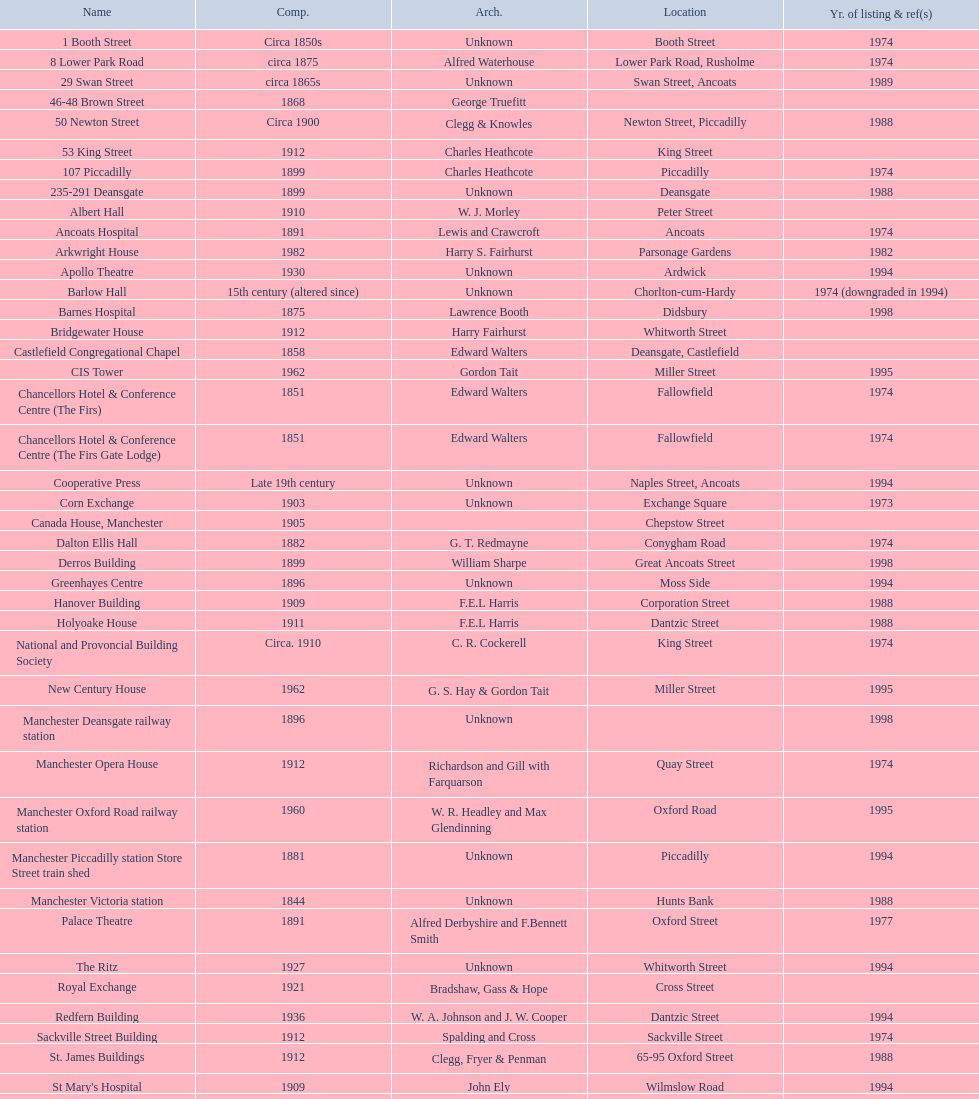Which two buildings were listed before 1974? The Old Wellington Inn, Smithfield Market Hall. Write the full table. {'header': ['Name', 'Comp.', 'Arch.', 'Location', 'Yr. of listing & ref(s)'], 'rows': [['1 Booth Street', 'Circa 1850s', 'Unknown', 'Booth Street', '1974'], ['8 Lower Park Road', 'circa 1875', 'Alfred Waterhouse', 'Lower Park Road, Rusholme', '1974'], ['29 Swan Street', 'circa 1865s', 'Unknown', 'Swan Street, Ancoats', '1989'], ['46-48 Brown Street', '1868', 'George Truefitt', '', ''], ['50 Newton Street', 'Circa 1900', 'Clegg & Knowles', 'Newton Street, Piccadilly', '1988'], ['53 King Street', '1912', 'Charles Heathcote', 'King Street', ''], ['107 Piccadilly', '1899', 'Charles Heathcote', 'Piccadilly', '1974'], ['235-291 Deansgate', '1899', 'Unknown', 'Deansgate', '1988'], ['Albert Hall', '1910', 'W. J. Morley', 'Peter Street', ''], ['Ancoats Hospital', '1891', 'Lewis and Crawcroft', 'Ancoats', '1974'], ['Arkwright House', '1982', 'Harry S. Fairhurst', 'Parsonage Gardens', '1982'], ['Apollo Theatre', '1930', 'Unknown', 'Ardwick', '1994'], ['Barlow Hall', '15th century (altered since)', 'Unknown', 'Chorlton-cum-Hardy', '1974 (downgraded in 1994)'], ['Barnes Hospital', '1875', 'Lawrence Booth', 'Didsbury', '1998'], ['Bridgewater House', '1912', 'Harry Fairhurst', 'Whitworth Street', ''], ['Castlefield Congregational Chapel', '1858', 'Edward Walters', 'Deansgate, Castlefield', ''], ['CIS Tower', '1962', 'Gordon Tait', 'Miller Street', '1995'], ['Chancellors Hotel & Conference Centre (The Firs)', '1851', 'Edward Walters', 'Fallowfield', '1974'], ['Chancellors Hotel & Conference Centre (The Firs Gate Lodge)', '1851', 'Edward Walters', 'Fallowfield', '1974'], ['Cooperative Press', 'Late 19th century', 'Unknown', 'Naples Street, Ancoats', '1994'], ['Corn Exchange', '1903', 'Unknown', 'Exchange Square', '1973'], ['Canada House, Manchester', '1905', '', 'Chepstow Street', ''], ['Dalton Ellis Hall', '1882', 'G. T. Redmayne', 'Conygham Road', '1974'], ['Derros Building', '1899', 'William Sharpe', 'Great Ancoats Street', '1998'], ['Greenhayes Centre', '1896', 'Unknown', 'Moss Side', '1994'], ['Hanover Building', '1909', 'F.E.L Harris', 'Corporation Street', '1988'], ['Holyoake House', '1911', 'F.E.L Harris', 'Dantzic Street', '1988'], ['National and Provoncial Building Society', 'Circa. 1910', 'C. R. Cockerell', 'King Street', '1974'], ['New Century House', '1962', 'G. S. Hay & Gordon Tait', 'Miller Street', '1995'], ['Manchester Deansgate railway station', '1896', 'Unknown', '', '1998'], ['Manchester Opera House', '1912', 'Richardson and Gill with Farquarson', 'Quay Street', '1974'], ['Manchester Oxford Road railway station', '1960', 'W. R. Headley and Max Glendinning', 'Oxford Road', '1995'], ['Manchester Piccadilly station Store Street train shed', '1881', 'Unknown', 'Piccadilly', '1994'], ['Manchester Victoria station', '1844', 'Unknown', 'Hunts Bank', '1988'], ['Palace Theatre', '1891', 'Alfred Derbyshire and F.Bennett Smith', 'Oxford Street', '1977'], ['The Ritz', '1927', 'Unknown', 'Whitworth Street', '1994'], ['Royal Exchange', '1921', 'Bradshaw, Gass & Hope', 'Cross Street', ''], ['Redfern Building', '1936', 'W. A. Johnson and J. W. Cooper', 'Dantzic Street', '1994'], ['Sackville Street Building', '1912', 'Spalding and Cross', 'Sackville Street', '1974'], ['St. James Buildings', '1912', 'Clegg, Fryer & Penman', '65-95 Oxford Street', '1988'], ["St Mary's Hospital", '1909', 'John Ely', 'Wilmslow Road', '1994'], ['Samuel Alexander Building', '1919', 'Percy Scott Worthington', 'Oxford Road', '2010'], ['Ship Canal House', '1927', 'Harry S. Fairhurst', 'King Street', '1982'], ['Smithfield Market Hall', '1857', 'Unknown', 'Swan Street, Ancoats', '1973'], ['Strangeways Gaol Gatehouse', '1868', 'Alfred Waterhouse', 'Sherborne Street', '1974'], ['Strangeways Prison ventilation and watch tower', '1868', 'Alfred Waterhouse', 'Sherborne Street', '1974'], ['Theatre Royal', '1845', 'Irwin and Chester', 'Peter Street', '1974'], ['Toast Rack', '1960', 'L. C. Howitt', 'Fallowfield', '1999'], ['The Old Wellington Inn', 'Mid-16th century', 'Unknown', 'Shambles Square', '1952'], ['Whitworth Park Mansions', 'Circa 1840s', 'Unknown', 'Whitworth Park', '1974']]} 